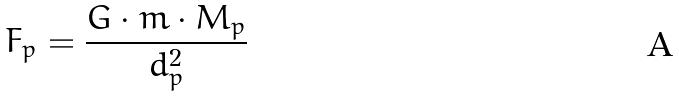<formula> <loc_0><loc_0><loc_500><loc_500>F _ { p } = \frac { G \cdot m \cdot M _ { p } } { d _ { p } ^ { 2 } }</formula> 